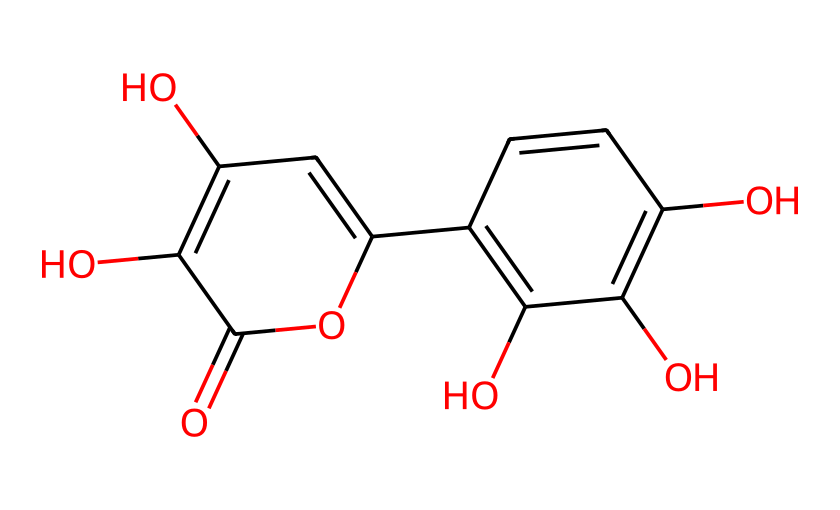What is the molecular formula of quercetin? To determine the molecular formula from the SMILES representation, we need to count the carbon (C), hydrogen (H), and oxygen (O) atoms. Analyzing the structure, we find there are 15 carbon atoms, 10 hydrogen atoms, and 7 oxygen atoms. Thus, the molecular formula is C15H10O7.
Answer: C15H10O7 How many hydroxyl (-OH) groups does quercetin contain? Upon examining the structure, we find that there are five -OH groups attached at various positions on the carbon atoms. These groups are indicated by the presence of oxygen atoms directly bonded to hydrogen atoms.
Answer: 5 What type of chemical compound is quercetin classified as? Quercetin is a flavonoid, which is a specific class of phytochemicals characterized by their polyphenolic structure. The multiple -OH groups and the carbon framework are indicative of flavonoids.
Answer: flavonoid What role does quercetin play in sports nutrition? Quercetin is known to enhance endurance and recovery due to its antioxidant properties, which combat oxidative stress during physical exertion. This is important for athletes for improved performance.
Answer: antioxidant How many rings are present in the molecular structure of quercetin? Quercetin contains two aromatic rings in its structure. These rings contribute to the stability and the chemical properties of the compound, typical of many flavonoids.
Answer: 2 Which part of the molecule contributes most to its antioxidant properties? The presence of multiple hydroxyl groups significantly enhances the antioxidant capacity of quercetin, as they can donate protons and neutralize free radicals. This structural feature is crucial for its protective effects.
Answer: hydroxyl groups 